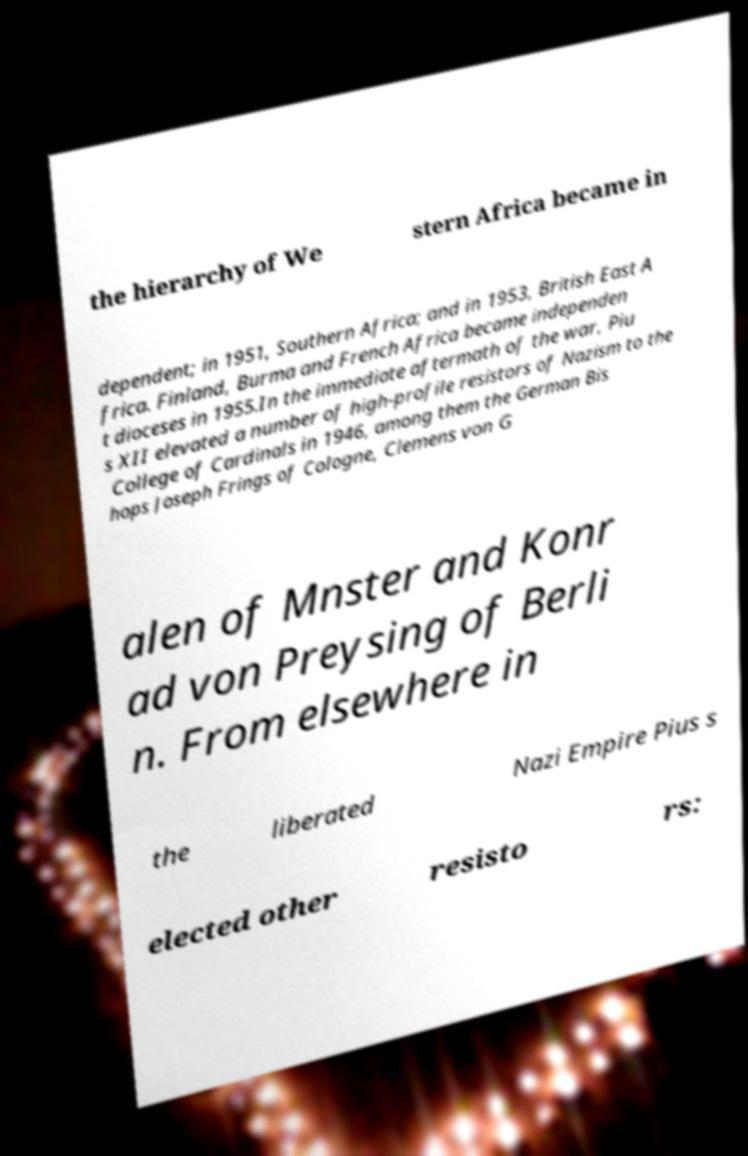There's text embedded in this image that I need extracted. Can you transcribe it verbatim? the hierarchy of We stern Africa became in dependent; in 1951, Southern Africa; and in 1953, British East A frica. Finland, Burma and French Africa became independen t dioceses in 1955.In the immediate aftermath of the war, Piu s XII elevated a number of high-profile resistors of Nazism to the College of Cardinals in 1946, among them the German Bis hops Joseph Frings of Cologne, Clemens von G alen of Mnster and Konr ad von Preysing of Berli n. From elsewhere in the liberated Nazi Empire Pius s elected other resisto rs: 